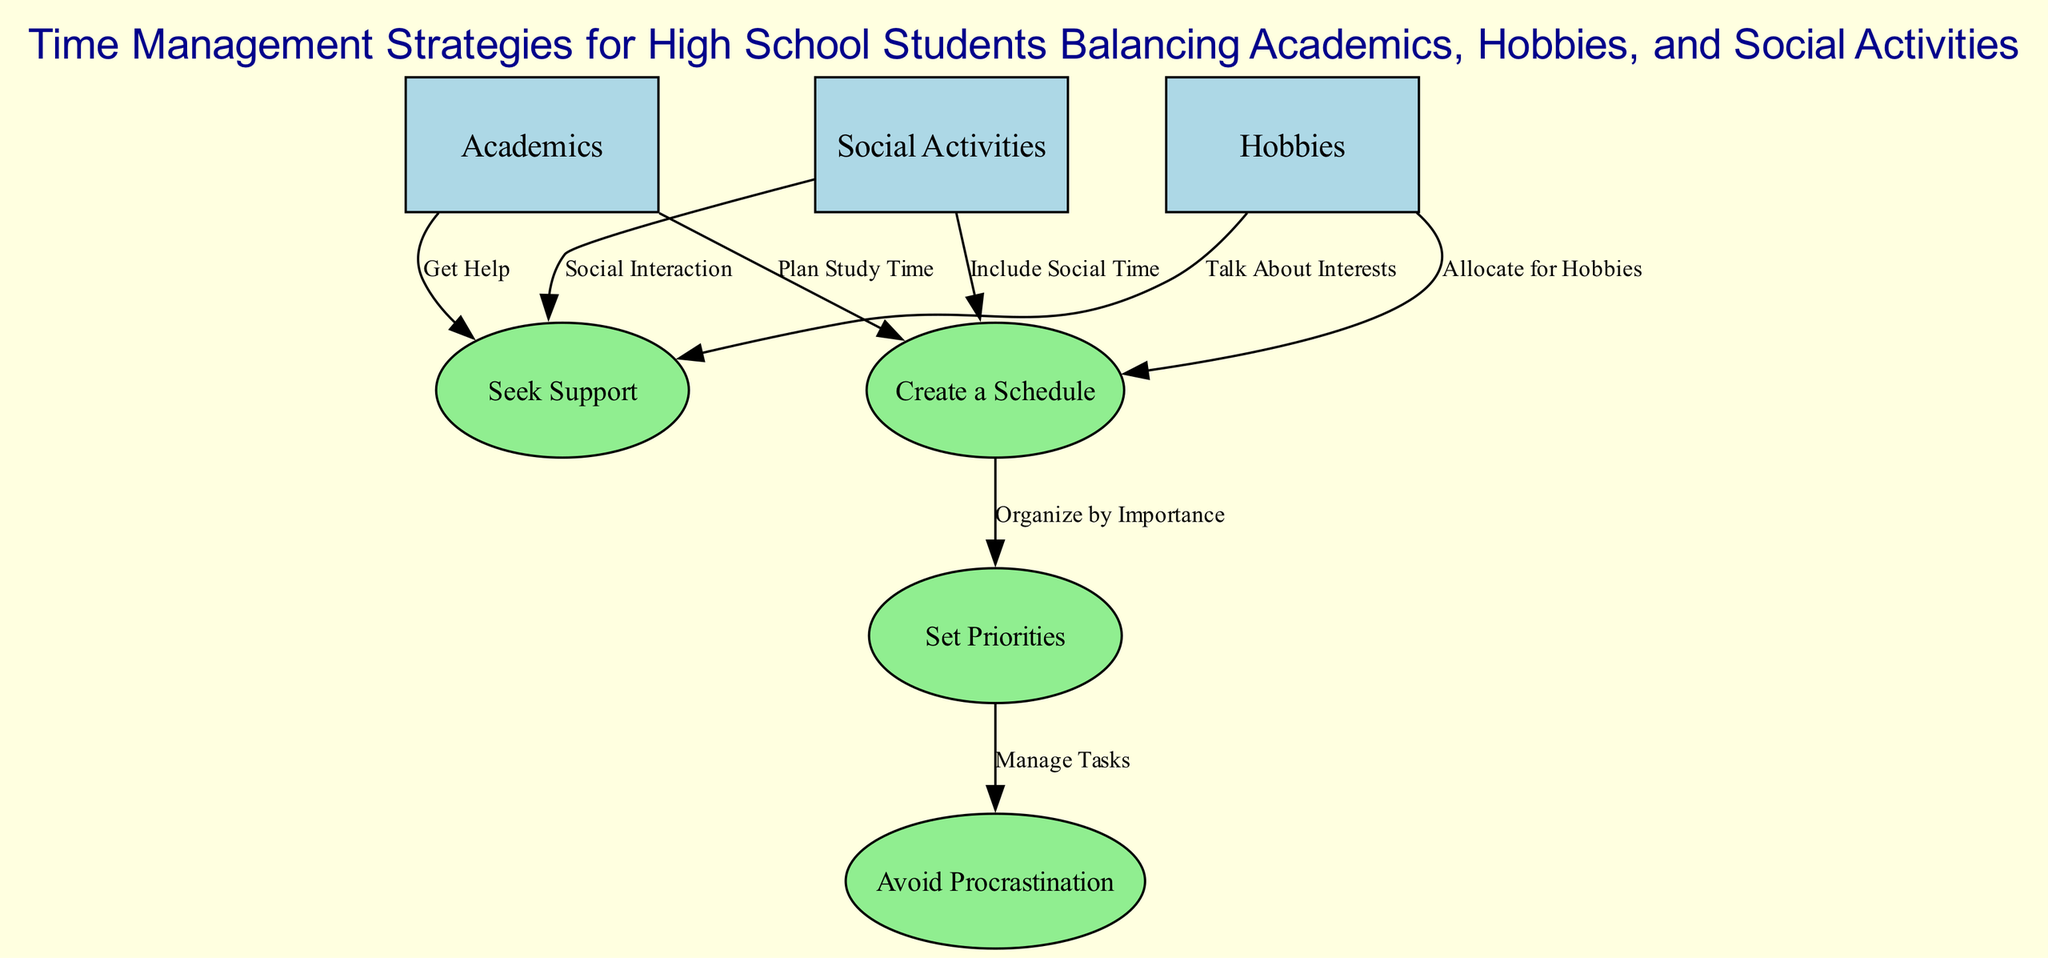What are the main categories represented in the diagram? The diagram has three main categories: Academics, Hobbies, and Social Activities. These are the primary nodes that represent different areas of time management for high school students.
Answer: Academics, Hobbies, Social Activities How many total nodes are there in the diagram? By counting the number of nodes listed in the diagram, there are a total of seven nodes, including the main categories and strategies.
Answer: 7 Which node describes seeking help when feeling overwhelmed? The node labeled "Seek Support" outlines the importance of talking to teachers, family, or friends when a student feels overwhelmed with their tasks.
Answer: Seek Support What is the relationship between "Create a Schedule" and "Set Priorities"? "Create a Schedule" is linked to "Set Priorities" because organizing activities is essential for determining which tasks are more important to focus on first.
Answer: Organize by Importance How does "Avoid Procrastination" connect with "Set Priorities"? "Avoid Procrastination" is dependent on "Set Priorities" since managing tasks is a critical part of tackling urgent tasks effectively, breaking them into smaller steps.
Answer: Manage Tasks Which two nodes suggest talking about personal interests? The nodes "Hobbies" and "Social Activities" both suggest discussing personal interests with others, which helps in feeling more connected and less anxious.
Answer: Hobbies, Social Activities What step should be taken after planning study time? After planning study time, the next step recommended in the diagram is to seek support if feeling overwhelmed, indicating the supportive nature of time management.
Answer: Get Help 